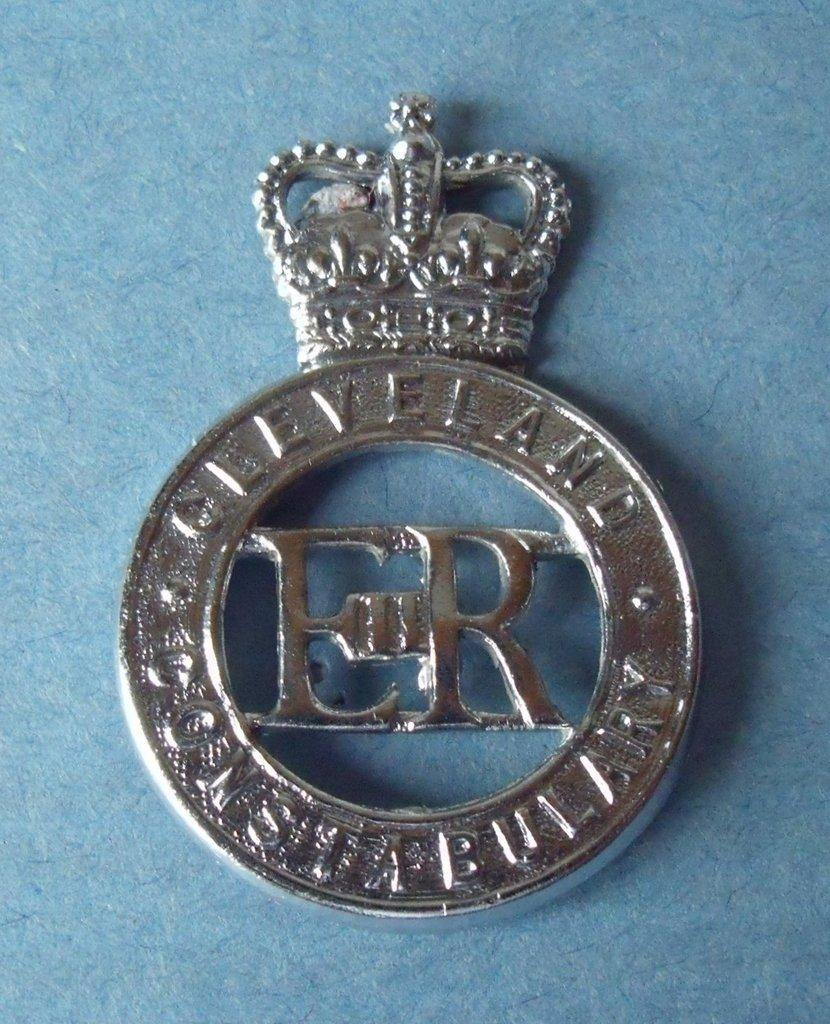What is the main subject of the image? There is an emblem in the center of the image. What type of pencil can be seen in the image? There is no pencil present in the image; the main subject is an emblem. What time of day is depicted in the image? The time of day cannot be determined from the image, as it only features an emblem. 